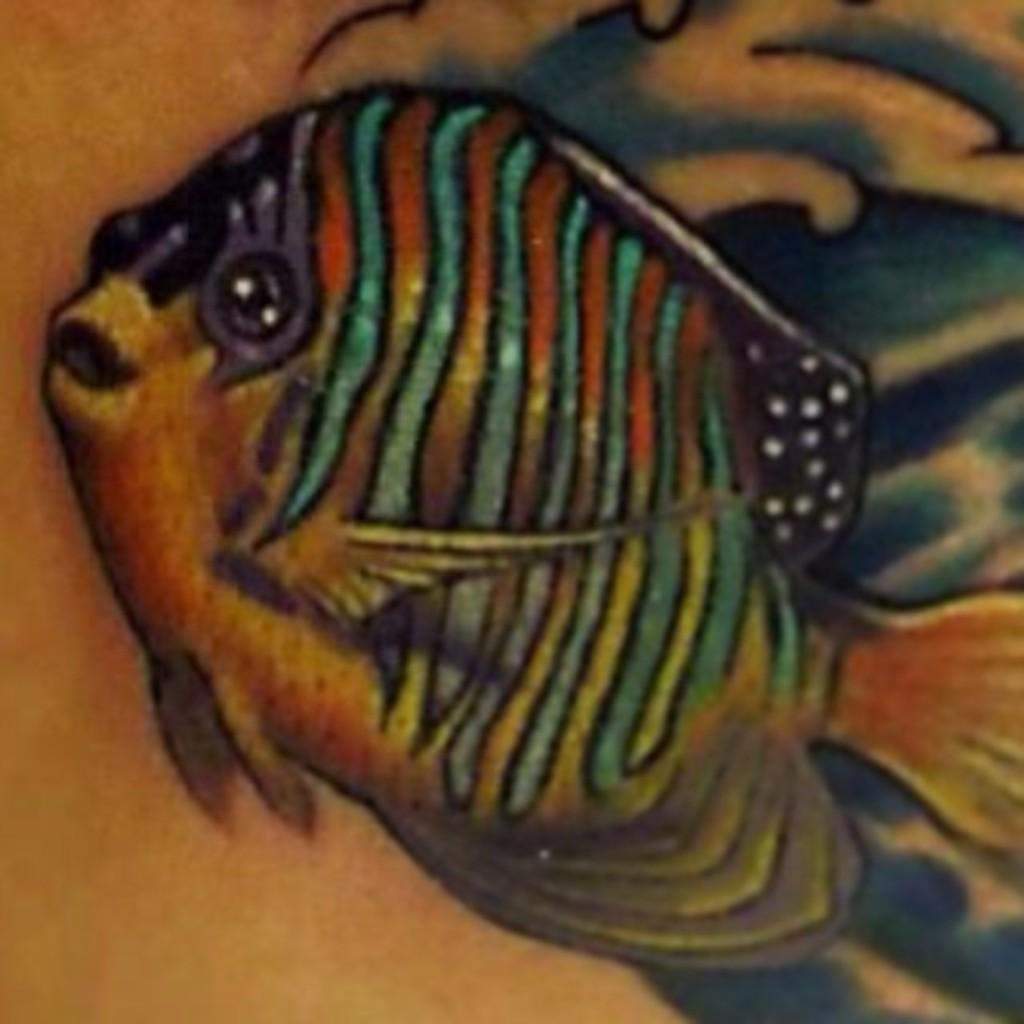What is the main subject of the image? The main subject of the image is an art of a fish. Can you describe the background in the image? Unfortunately, the provided facts do not give any information about the background in the image. How many nails are used to hang the fish art in the image? There is no information about nails or hanging the art in the provided facts, and therefore we cannot answer this question. 